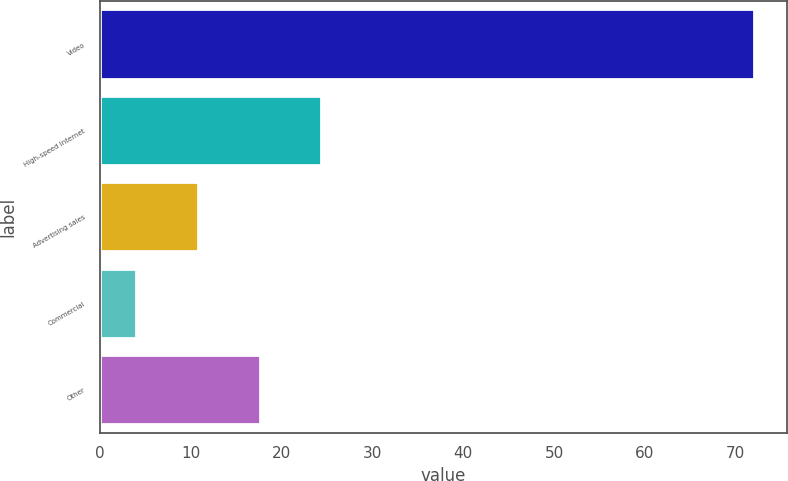<chart> <loc_0><loc_0><loc_500><loc_500><bar_chart><fcel>Video<fcel>High-speed Internet<fcel>Advertising sales<fcel>Commercial<fcel>Other<nl><fcel>72<fcel>24.4<fcel>10.8<fcel>4<fcel>17.6<nl></chart> 